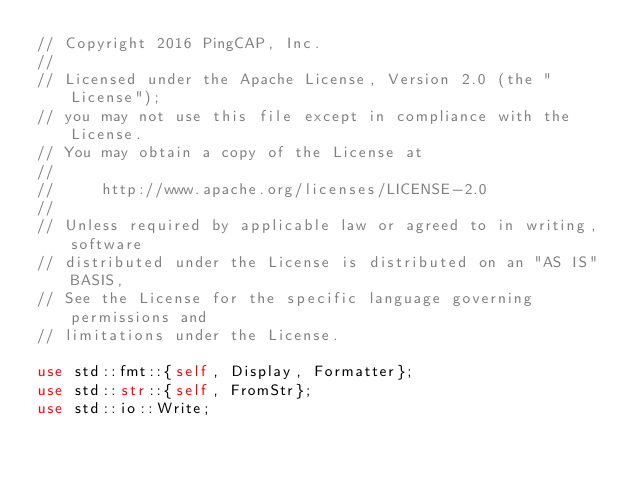Convert code to text. <code><loc_0><loc_0><loc_500><loc_500><_Rust_>// Copyright 2016 PingCAP, Inc.
//
// Licensed under the Apache License, Version 2.0 (the "License");
// you may not use this file except in compliance with the License.
// You may obtain a copy of the License at
//
//     http://www.apache.org/licenses/LICENSE-2.0
//
// Unless required by applicable law or agreed to in writing, software
// distributed under the License is distributed on an "AS IS" BASIS,
// See the License for the specific language governing permissions and
// limitations under the License.

use std::fmt::{self, Display, Formatter};
use std::str::{self, FromStr};
use std::io::Write;</code> 